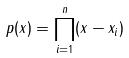Convert formula to latex. <formula><loc_0><loc_0><loc_500><loc_500>p ( x ) = \prod _ { i = 1 } ^ { n } ( x - x _ { i } )</formula> 